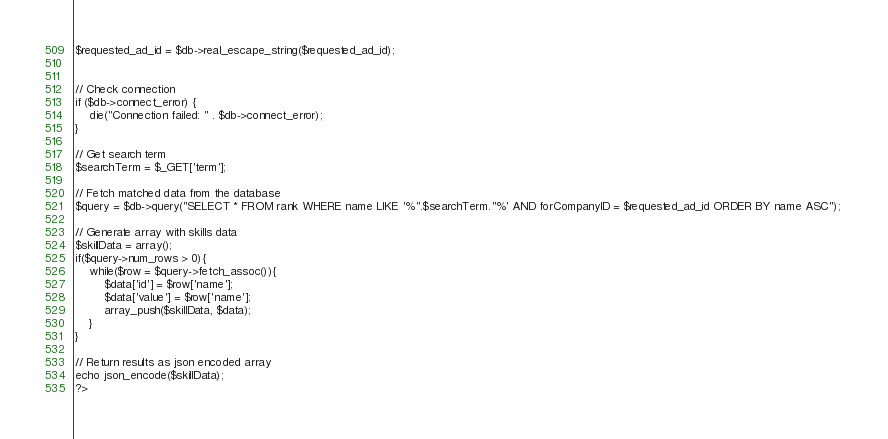<code> <loc_0><loc_0><loc_500><loc_500><_PHP_>$requested_ad_id = $db->real_escape_string($requested_ad_id);

 
// Check connection 
if ($db->connect_error) { 
    die("Connection failed: " . $db->connect_error); 
} 
 
// Get search term 
$searchTerm = $_GET['term']; 
 
// Fetch matched data from the database 
$query = $db->query("SELECT * FROM rank WHERE name LIKE '%".$searchTerm."%' AND forCompanyID = $requested_ad_id ORDER BY name ASC"); 
 
// Generate array with skills data 
$skillData = array(); 
if($query->num_rows > 0){ 
    while($row = $query->fetch_assoc()){ 
        $data['id'] = $row['name']; 
        $data['value'] = $row['name']; 
        array_push($skillData, $data); 
    } 
} 
 
// Return results as json encoded array 
echo json_encode($skillData); 
?>
</code> 